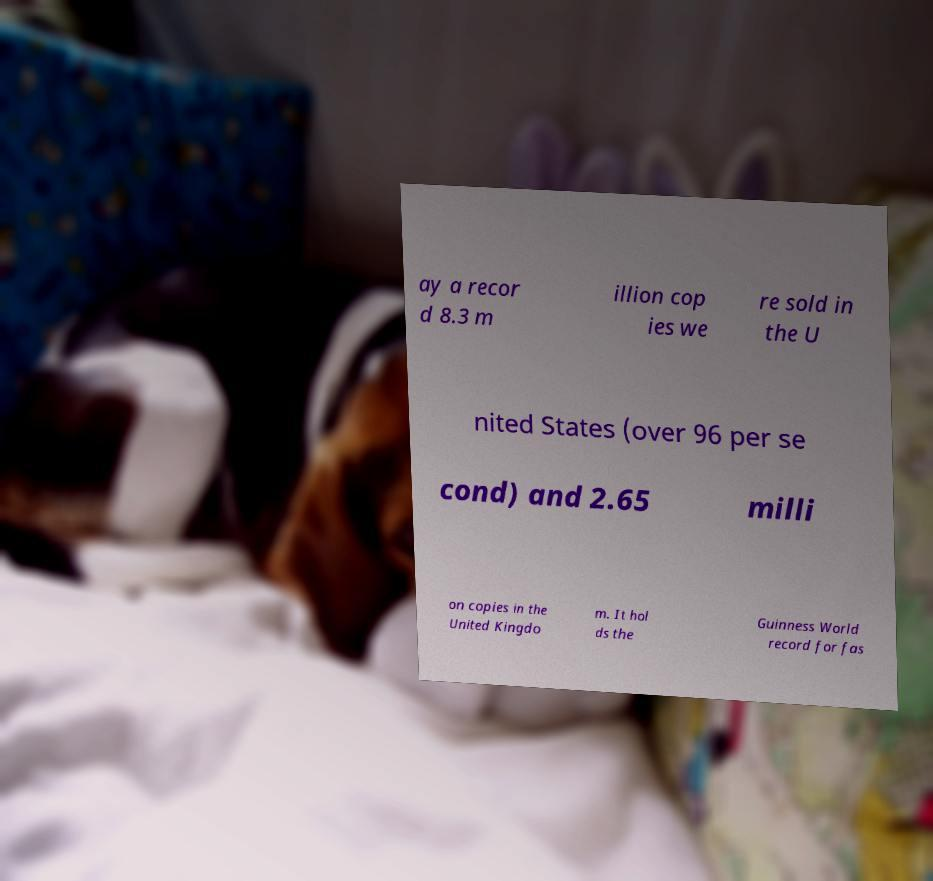Please identify and transcribe the text found in this image. ay a recor d 8.3 m illion cop ies we re sold in the U nited States (over 96 per se cond) and 2.65 milli on copies in the United Kingdo m. It hol ds the Guinness World record for fas 